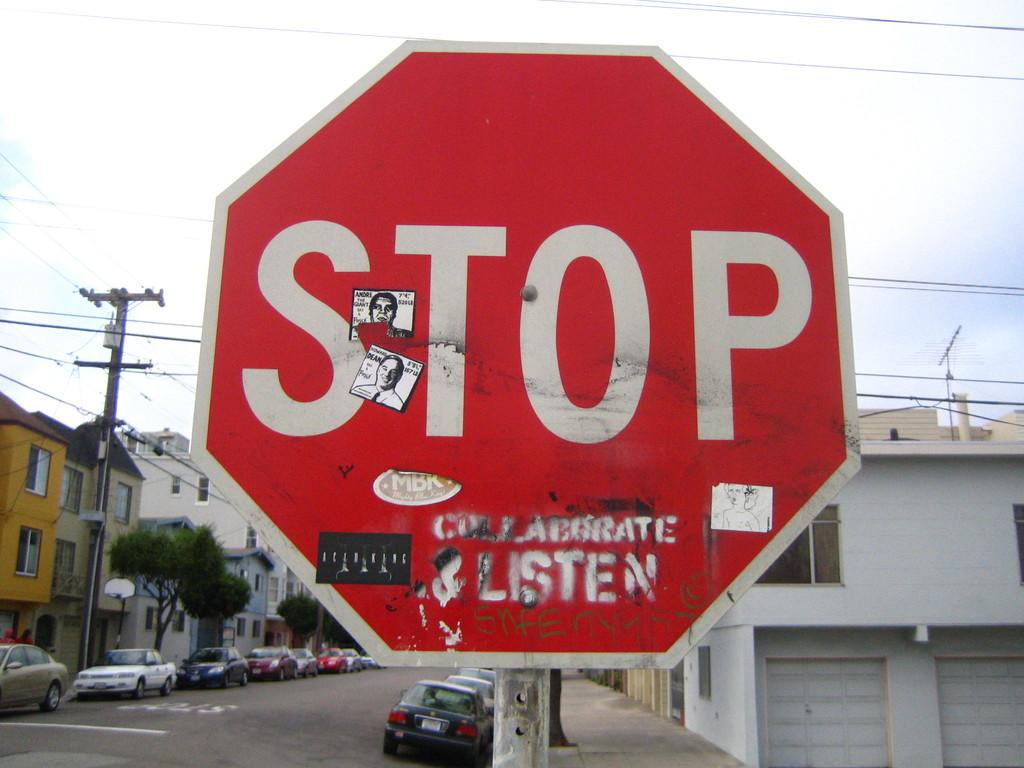Provide a one-sentence caption for the provided image. A stop sign with a lot of stickers on it. 